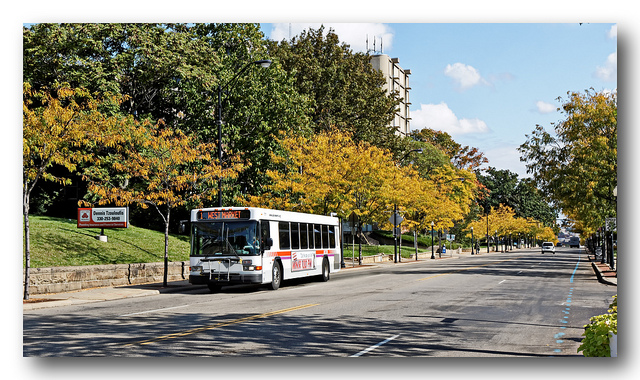<image>There are people in the bus? I am not sure if there are people in the bus. It could be yes or no. What color is the fire hydrant? I am not sure what color the fire hydrant is. It could be silver, blue, red, or white. Where is the bus going? I don't know where the bus is going. It can be going to 'west market', 'cleveland', 'into city', 'to town' or 'downtown'. There are people in the bus? I am not sure if there are people in the bus. It can be both yes or no. What color is the fire hydrant? There is a fire hydrant in the image, but I don't know its color. It can be red or white. Where is the bus going? I don't know where the bus is going. It can be going to West Market, Cleveland, downtown, or somewhere else. 